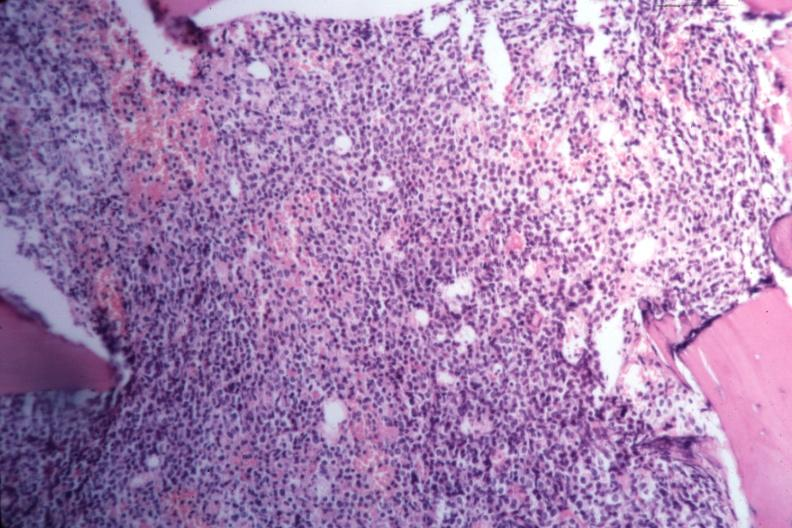what is present?
Answer the question using a single word or phrase. Acute myelogenous leukemia 